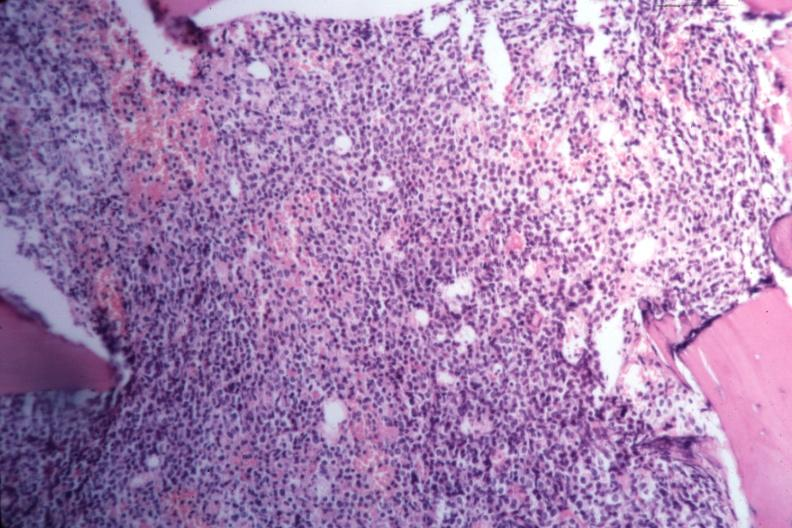what is present?
Answer the question using a single word or phrase. Acute myelogenous leukemia 